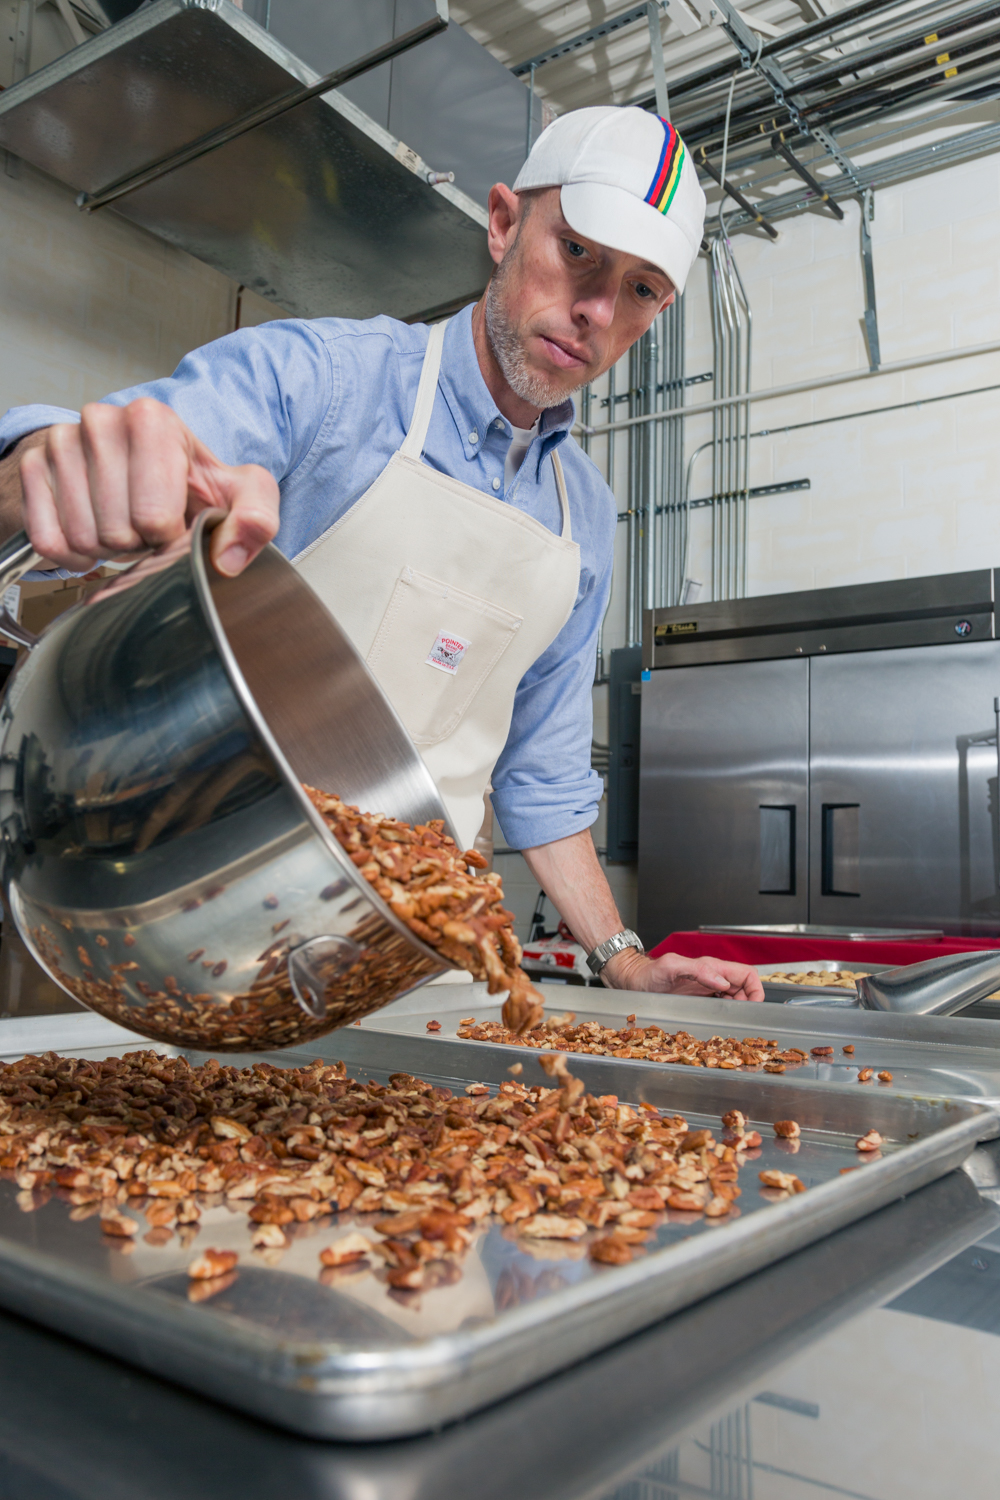If this kitchen were converted into a research facility, what kind of food-related research might take place here? If this kitchen were converted into a research facility, it might focus on researching new methods of food preservation, developing innovative recipes, or experimenting with alternative ingredients for health-conscious consumers. Researchers could be working on enhancing the shelf life of products like roasted nuts, creating unique flavor combinations, or studying the nutritional benefits of different nuts and their impact on overall health. The facility could also be involved in food safety research, developing new protocols to ensure the highest standards of hygiene and quality in food production. Describe a futuristic experiment that could be conducted in this research facility. A futuristic experiment in this research facility could involve the use of 3D printing technology to create personalized nut-based snacks tailored to individual dietary needs and preferences. Researchers could explore how to blend different nuts with various natural ingredients to produce bespoke snack items that cater to specific health requirements. They might also investigate the potential of using artificial intelligence to predict flavor profiles that will be most popular among different demographic groups, thus revolutionizing the way snacks are produced and marketed. 